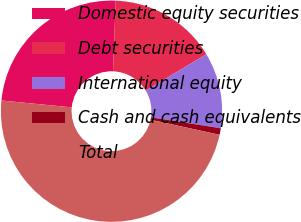Convert chart to OTSL. <chart><loc_0><loc_0><loc_500><loc_500><pie_chart><fcel>Domestic equity securities<fcel>Debt securities<fcel>International equity<fcel>Cash and cash equivalents<fcel>Total<nl><fcel>24.06%<fcel>15.78%<fcel>11.07%<fcel>0.96%<fcel>48.12%<nl></chart> 